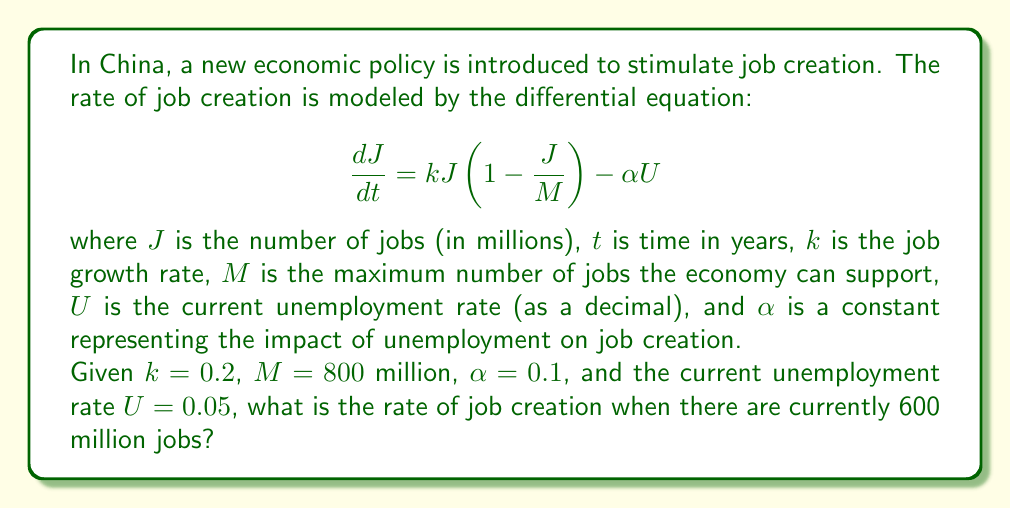Show me your answer to this math problem. To solve this problem, we need to use the given differential equation and substitute the known values. Let's break it down step-by-step:

1. The differential equation is:
   $$\frac{dJ}{dt} = kJ(1 - \frac{J}{M}) - \alpha U$$

2. We are given the following values:
   - $k = 0.2$
   - $M = 800$ million
   - $\alpha = 0.1$
   - $U = 0.05$
   - $J = 600$ million (current number of jobs)

3. Let's substitute these values into the equation:
   $$\frac{dJ}{dt} = 0.2 \cdot 600 \cdot (1 - \frac{600}{800}) - 0.1 \cdot 0.05$$

4. Simplify the expression inside the parentheses:
   $$\frac{dJ}{dt} = 0.2 \cdot 600 \cdot (1 - 0.75) - 0.1 \cdot 0.05$$
   $$\frac{dJ}{dt} = 0.2 \cdot 600 \cdot 0.25 - 0.1 \cdot 0.05$$

5. Multiply the terms:
   $$\frac{dJ}{dt} = 30 - 0.005$$

6. Calculate the final result:
   $$\frac{dJ}{dt} = 29.995$$

Therefore, the rate of job creation when there are 600 million jobs is 29.995 million jobs per year.
Answer: 29.995 million jobs per year 